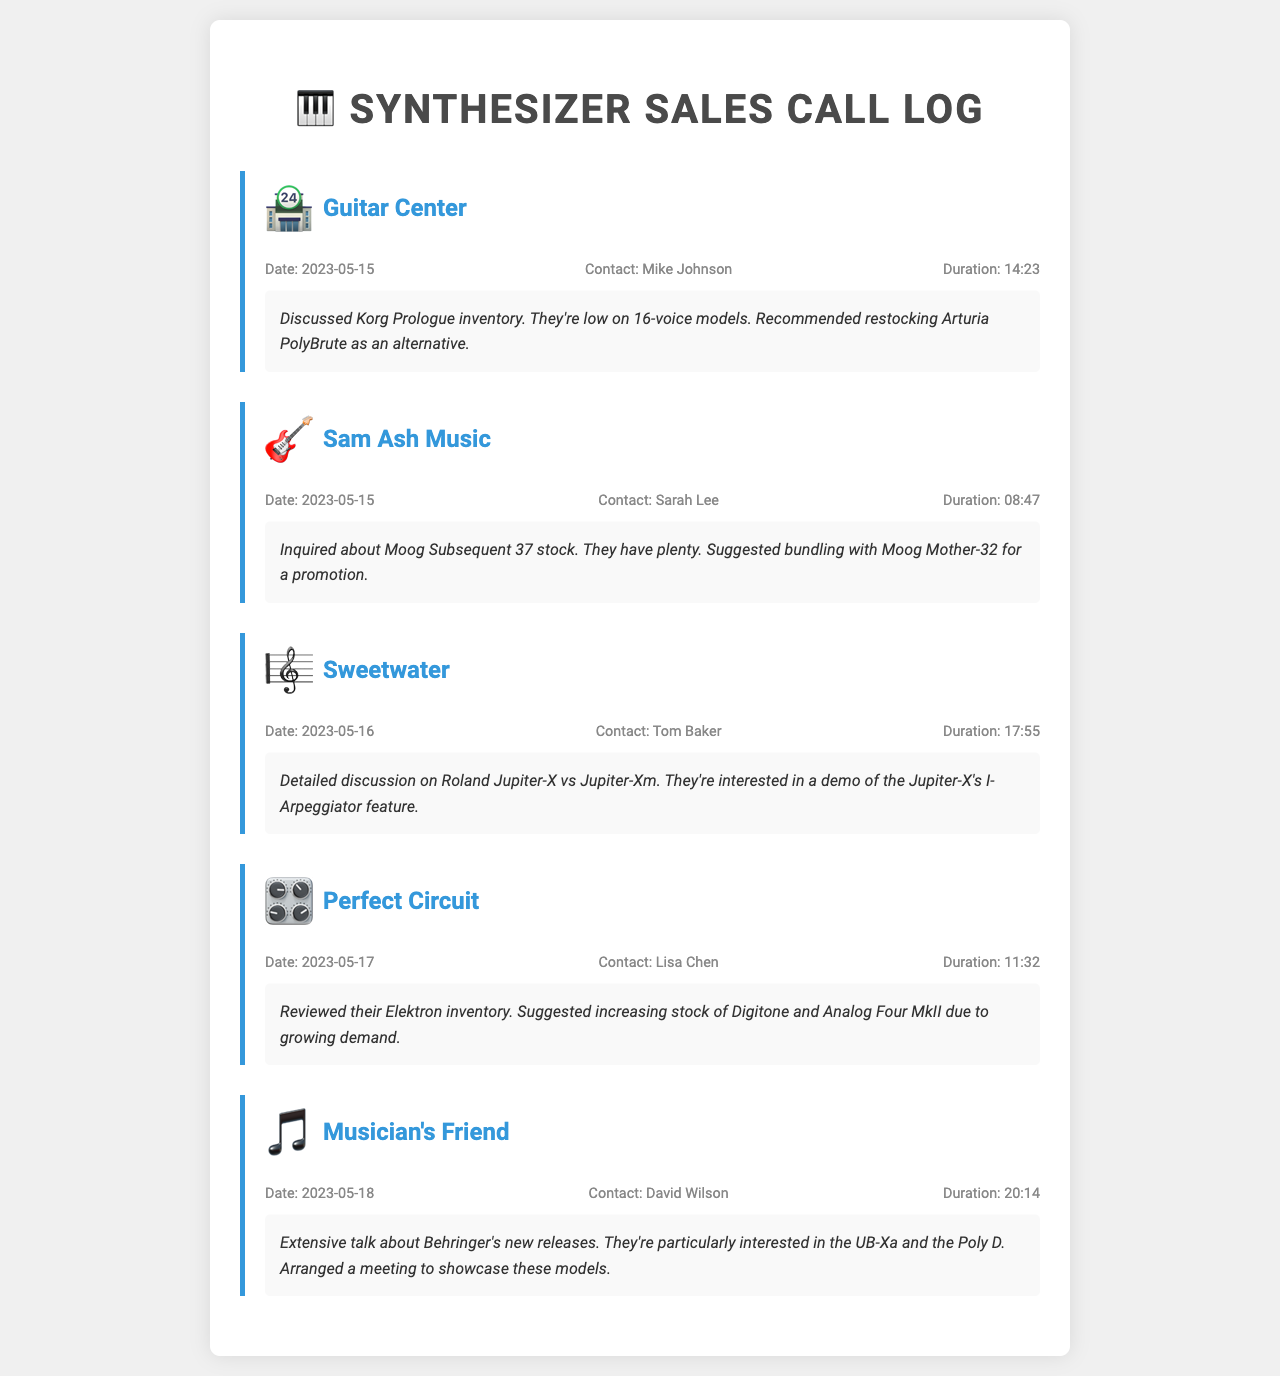What is the date of the call to Guitar Center? The date for the call made to Guitar Center is specified in the call log.
Answer: 2023-05-15 Who did the salesperson speak with at Sam Ash Music? The document specifies the contact person for the call to Sam Ash Music.
Answer: Sarah Lee What synthesizers were discussed during the call with Musician's Friend? The notes section indicates the synthesizers that were specifically mentioned during the call.
Answer: UB-Xa and Poly D How long was the call with Sweetwater? The duration of the call is detailed in the call log for Sweetwater.
Answer: 17:55 What alternative synthesizer was suggested for Korg Prologue? The notes indicate a recommendation for a different synthesizer as an alternative to the Korg Prologue.
Answer: Arturia PolyBrute What feature of the Jupiter-X were they interested in? The document mentions the specific feature of the Jupiter-X that was a point of interest during the call.
Answer: I-Arpeggiator How many minutes did the call with Perfect Circuit last? The call duration is clearly stated in the call log for Perfect Circuit.
Answer: 11:32 What was the purpose of the call with Musician's Friend? The notes detail the main focus or purpose of the conversation during the call.
Answer: Showcase these models 